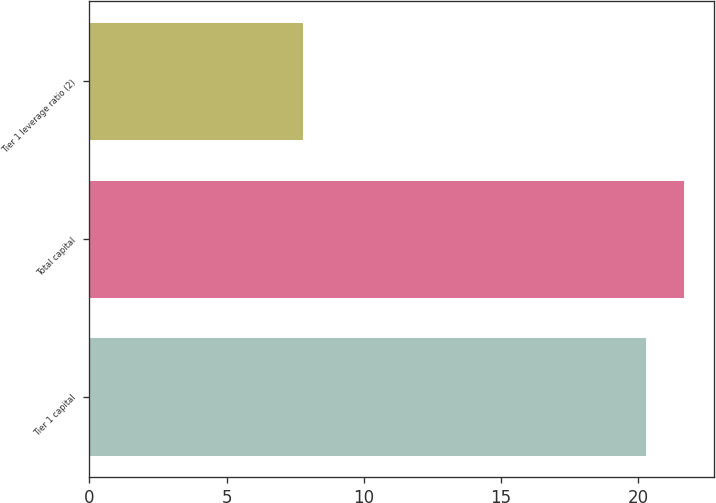<chart> <loc_0><loc_0><loc_500><loc_500><bar_chart><fcel>Tier 1 capital<fcel>Total capital<fcel>Tier 1 leverage ratio (2)<nl><fcel>20.3<fcel>21.68<fcel>7.8<nl></chart> 